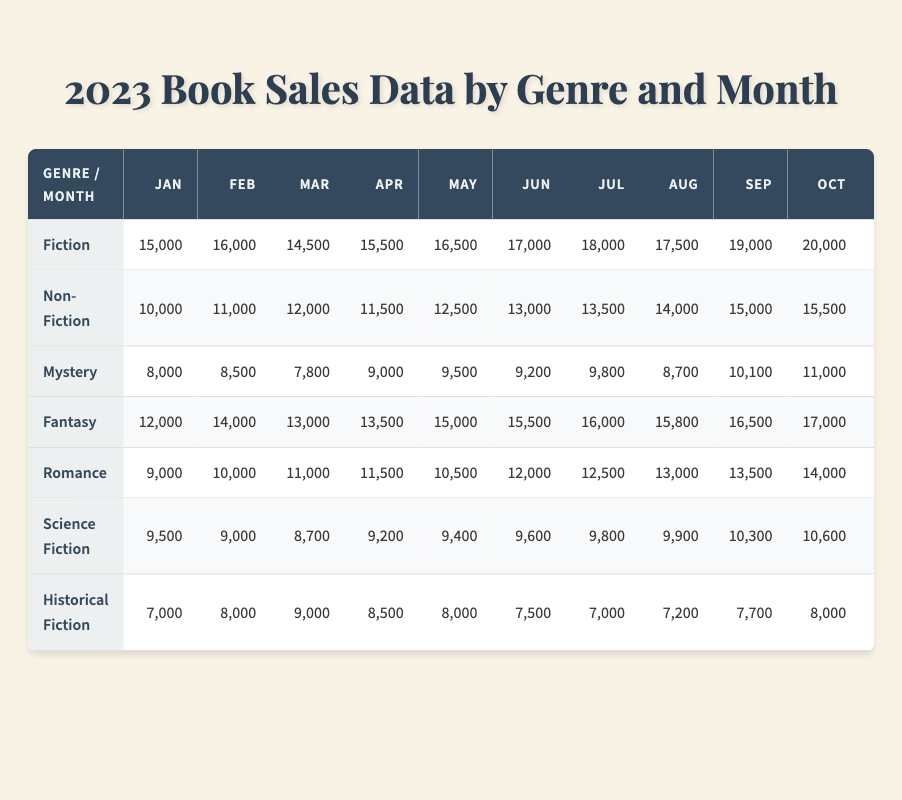What was the total number of Fiction books sold in December? In December, the Fiction genre sold 22,500 books. This value can be directly found in the table under the December column for Fiction.
Answer: 22,500 Which genre sold the most books in September? In September, the Fiction genre sold 19,000 books, which is more than any other genre listed for that month.
Answer: Fiction What is the difference in sales between Fantasy and Romance in July? In July, Fantasy sold 16,000 books and Romance sold 12,500 books. The difference is calculated by subtracting Romance sales from Fantasy sales: 16,000 - 12,500 = 3,500.
Answer: 3,500 Did Historical Fiction sell more than Science Fiction in any month? By comparing the two genres across all months, Historical Fiction sold more in January, March, April, June, July, August, and September, while Science Fiction had higher sales in every other month.
Answer: Yes What was the average monthly sales of Non-Fiction for the year? To find the average, sum the sales of Non-Fiction from each month (10,000 + 11,000 + 12,000 + 11,500 + 12,500 + 13,000 + 13,500 + 14,000 + 15,000 + 15,500 + 16,000 + 17,000) which equals 158,500. Then divide by 12 months: 158,500 / 12 = 13,208.33.
Answer: 13,208.33 Which month had the highest sales in Mystery? Looking through the table, December shows the highest sales in the Mystery genre with 12,000 books sold.
Answer: December What is the total number of books sold across all genres in October? To find the total for October, sum the sales for all genres: (20,000 + 15,500 + 11,000 + 17,000 + 14,000 + 10,600 + 8,000) = 96,100.
Answer: 96,100 Which month had the lowest sales for Science Fiction? By examining the table, it is clear that February showed the lowest sales for Science Fiction, with 9,000 books sold.
Answer: February How much more did Fantasy sell compared to Historical Fiction in May? In May, Fantasy sold 15,000 books and Historical Fiction sold 8,000 books. The difference is 15,000 - 8,000 = 7,000.
Answer: 7,000 What are the trends observed in Romance sales from January to December? Romance sales began at 9,000 in January and increased each month to reach 15,000 in December, indicating a steady growth trend over the year.
Answer: Steady growth Which genre consistently sold the least throughout the year? Historical Fiction had the lowest sales compared to other genres in every month throughout the year, confirming its position as the least sold genre.
Answer: Historical Fiction 